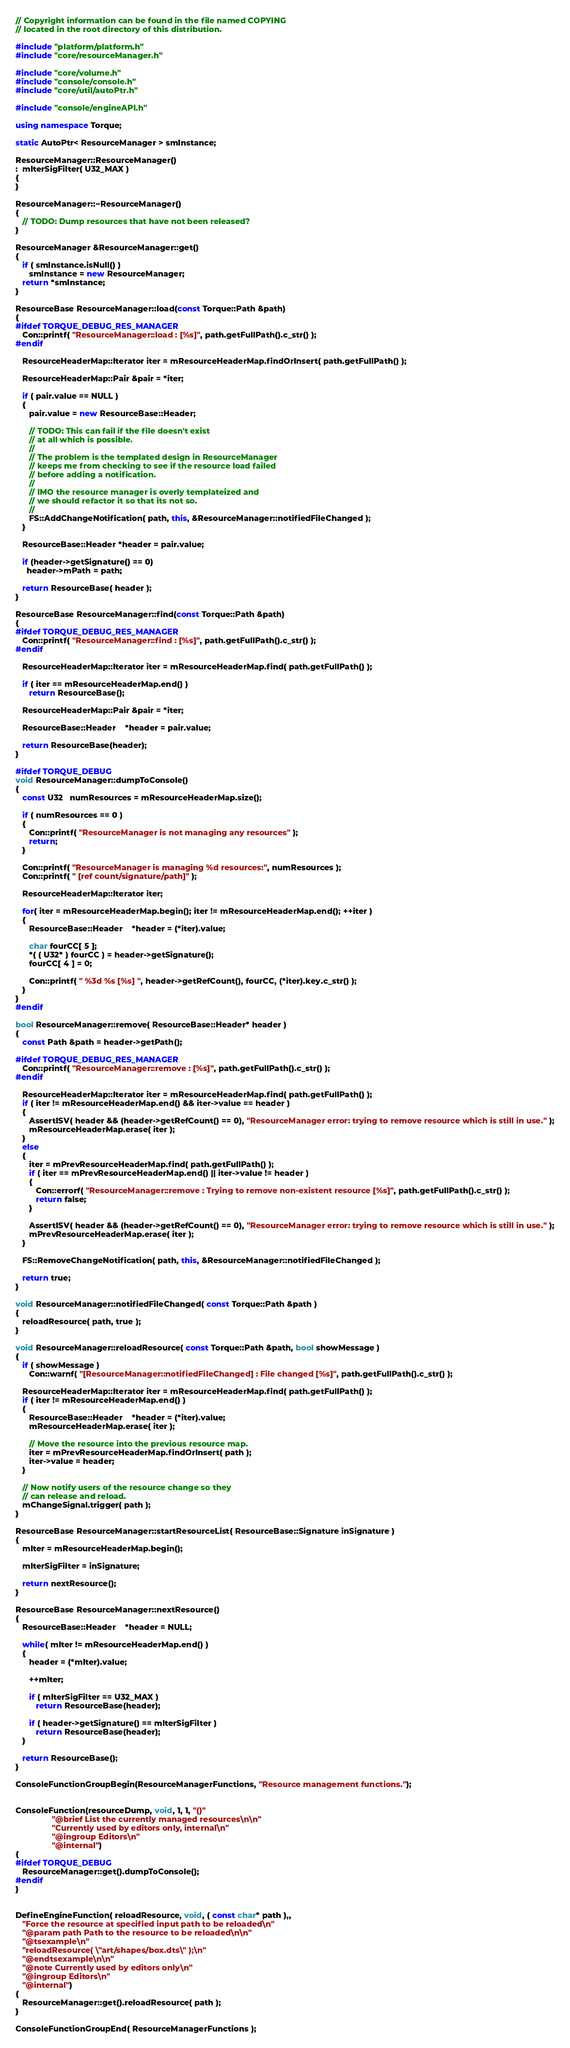Convert code to text. <code><loc_0><loc_0><loc_500><loc_500><_C++_>// Copyright information can be found in the file named COPYING
// located in the root directory of this distribution.

#include "platform/platform.h"
#include "core/resourceManager.h"

#include "core/volume.h"
#include "console/console.h"
#include "core/util/autoPtr.h"

#include "console/engineAPI.h"

using namespace Torque;

static AutoPtr< ResourceManager > smInstance;

ResourceManager::ResourceManager()
:  mIterSigFilter( U32_MAX )
{
}

ResourceManager::~ResourceManager()
{
   // TODO: Dump resources that have not been released?
}

ResourceManager &ResourceManager::get()
{
   if ( smInstance.isNull() )
      smInstance = new ResourceManager;
   return *smInstance;
}

ResourceBase ResourceManager::load(const Torque::Path &path)
{
#ifdef TORQUE_DEBUG_RES_MANAGER
   Con::printf( "ResourceManager::load : [%s]", path.getFullPath().c_str() );
#endif

   ResourceHeaderMap::Iterator iter = mResourceHeaderMap.findOrInsert( path.getFullPath() );

   ResourceHeaderMap::Pair &pair = *iter;

   if ( pair.value == NULL )
   {
      pair.value = new ResourceBase::Header;

      // TODO: This can fail if the file doesn't exist 
      // at all which is possible.
      //
      // The problem is the templated design in ResourceManager
      // keeps me from checking to see if the resource load failed
      // before adding a notification.
      //
      // IMO the resource manager is overly templateized and
      // we should refactor it so that its not so.
      //
      FS::AddChangeNotification( path, this, &ResourceManager::notifiedFileChanged );
   }

   ResourceBase::Header *header = pair.value;

   if (header->getSignature() == 0)
     header->mPath = path;

   return ResourceBase( header );
}

ResourceBase ResourceManager::find(const Torque::Path &path)
{
#ifdef TORQUE_DEBUG_RES_MANAGER
   Con::printf( "ResourceManager::find : [%s]", path.getFullPath().c_str() );
#endif

   ResourceHeaderMap::Iterator iter = mResourceHeaderMap.find( path.getFullPath() );

   if ( iter == mResourceHeaderMap.end() )
      return ResourceBase();

   ResourceHeaderMap::Pair &pair = *iter;

   ResourceBase::Header	*header = pair.value;

   return ResourceBase(header);
}

#ifdef TORQUE_DEBUG
void ResourceManager::dumpToConsole()
{
   const U32   numResources = mResourceHeaderMap.size();

   if ( numResources == 0 )
   {
      Con::printf( "ResourceManager is not managing any resources" );
      return;
   }

   Con::printf( "ResourceManager is managing %d resources:", numResources );
   Con::printf( " [ref count/signature/path]" );

   ResourceHeaderMap::Iterator iter;

   for( iter = mResourceHeaderMap.begin(); iter != mResourceHeaderMap.end(); ++iter )
   {
      ResourceBase::Header	*header = (*iter).value;
            
      char fourCC[ 5 ];
      *( ( U32* ) fourCC ) = header->getSignature();
      fourCC[ 4 ] = 0;

      Con::printf( " %3d %s [%s] ", header->getRefCount(), fourCC, (*iter).key.c_str() );
   }
}
#endif

bool ResourceManager::remove( ResourceBase::Header* header )
{
   const Path &path = header->getPath();

#ifdef TORQUE_DEBUG_RES_MANAGER
   Con::printf( "ResourceManager::remove : [%s]", path.getFullPath().c_str() );
#endif

   ResourceHeaderMap::Iterator iter = mResourceHeaderMap.find( path.getFullPath() );
   if ( iter != mResourceHeaderMap.end() && iter->value == header )
   {
      AssertISV( header && (header->getRefCount() == 0), "ResourceManager error: trying to remove resource which is still in use." );
      mResourceHeaderMap.erase( iter );
   }
   else
   {
      iter = mPrevResourceHeaderMap.find( path.getFullPath() );
      if ( iter == mPrevResourceHeaderMap.end() || iter->value != header )
      {
         Con::errorf( "ResourceManager::remove : Trying to remove non-existent resource [%s]", path.getFullPath().c_str() );
         return false;
      }

      AssertISV( header && (header->getRefCount() == 0), "ResourceManager error: trying to remove resource which is still in use." );
      mPrevResourceHeaderMap.erase( iter );
   }

   FS::RemoveChangeNotification( path, this, &ResourceManager::notifiedFileChanged );

   return true;
}

void ResourceManager::notifiedFileChanged( const Torque::Path &path )
{
   reloadResource( path, true );
}

void ResourceManager::reloadResource( const Torque::Path &path, bool showMessage )
{
   if ( showMessage )
      Con::warnf( "[ResourceManager::notifiedFileChanged] : File changed [%s]", path.getFullPath().c_str() );

   ResourceHeaderMap::Iterator iter = mResourceHeaderMap.find( path.getFullPath() );
   if ( iter != mResourceHeaderMap.end() )
   {
      ResourceBase::Header	*header = (*iter).value;
      mResourceHeaderMap.erase( iter );

      // Move the resource into the previous resource map.
      iter = mPrevResourceHeaderMap.findOrInsert( path );
      iter->value = header;
   }
	
   // Now notify users of the resource change so they 
   // can release and reload.
   mChangeSignal.trigger( path );
}

ResourceBase ResourceManager::startResourceList( ResourceBase::Signature inSignature )
{
   mIter = mResourceHeaderMap.begin();

   mIterSigFilter = inSignature;

   return nextResource();
}

ResourceBase ResourceManager::nextResource()
{
   ResourceBase::Header	*header = NULL;

   while( mIter != mResourceHeaderMap.end() )
   {
      header = (*mIter).value;

      ++mIter;

      if ( mIterSigFilter == U32_MAX )
         return ResourceBase(header);

      if ( header->getSignature() == mIterSigFilter )
         return ResourceBase(header);
   }
   
   return ResourceBase();
}

ConsoleFunctionGroupBegin(ResourceManagerFunctions, "Resource management functions.");


ConsoleFunction(resourceDump, void, 1, 1, "()"
				"@brief List the currently managed resources\n\n"
				"Currently used by editors only, internal\n"
				"@ingroup Editors\n"
				"@internal")
{
#ifdef TORQUE_DEBUG
   ResourceManager::get().dumpToConsole();
#endif
}


DefineEngineFunction( reloadResource, void, ( const char* path ),,
   "Force the resource at specified input path to be reloaded\n"
   "@param path Path to the resource to be reloaded\n\n"
   "@tsexample\n"
   "reloadResource( \"art/shapes/box.dts\" );\n"
   "@endtsexample\n\n"
   "@note Currently used by editors only\n"
   "@ingroup Editors\n"
   "@internal")
{
   ResourceManager::get().reloadResource( path );
}

ConsoleFunctionGroupEnd( ResourceManagerFunctions );
</code> 